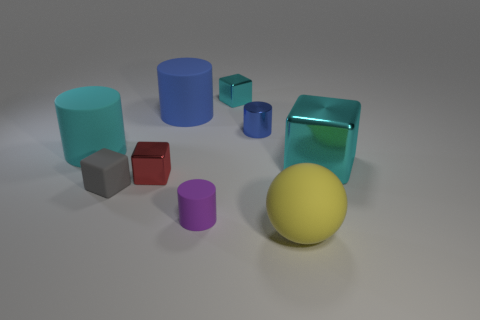How many things are either matte things that are behind the big shiny thing or small metallic blocks to the left of the purple matte cylinder?
Offer a very short reply. 3. Is there a tiny shiny cylinder behind the tiny metal cube behind the metal cylinder?
Provide a short and direct response. No. There is a gray object that is the same size as the red metallic thing; what shape is it?
Your answer should be compact. Cube. How many objects are either cyan things that are on the left side of the big cyan shiny thing or small shiny cylinders?
Provide a short and direct response. 3. What number of other things are the same material as the large blue cylinder?
Ensure brevity in your answer.  4. There is a metallic object that is the same color as the big metal cube; what shape is it?
Offer a terse response. Cube. What size is the rubber cylinder that is in front of the small gray rubber thing?
Your answer should be compact. Small. There is a small purple object that is made of the same material as the large ball; what is its shape?
Your answer should be very brief. Cylinder. Do the yellow ball and the cylinder that is in front of the large cyan block have the same material?
Your response must be concise. Yes. There is a tiny thing that is left of the small red object; is it the same shape as the blue rubber thing?
Offer a terse response. No. 